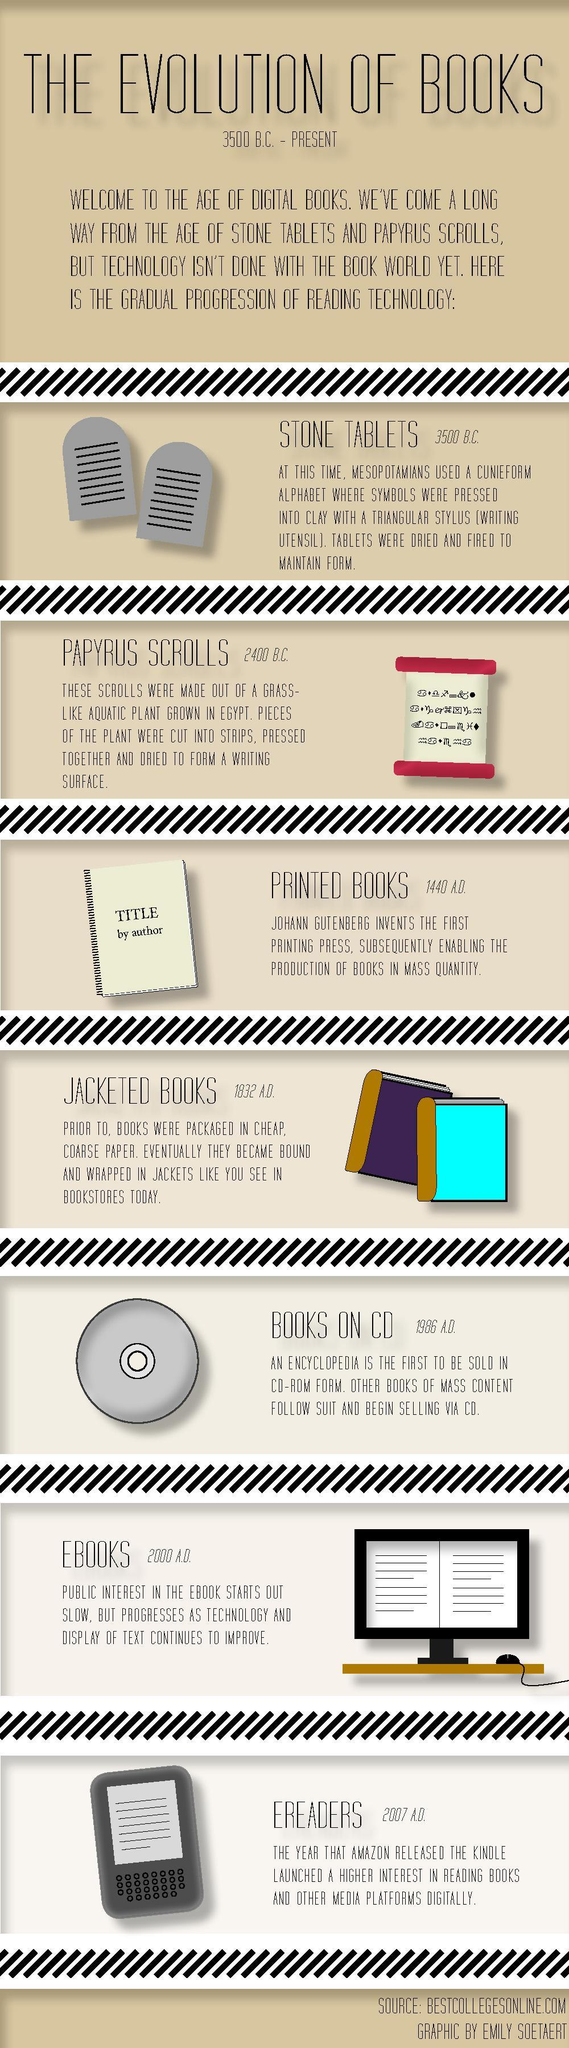Which device is used for reading digital e-books?
Answer the question with a short phrase. EREADERS When was the first printing press invented? 1440 A.D. What is the book publication made in digital form called? EBOOKS 